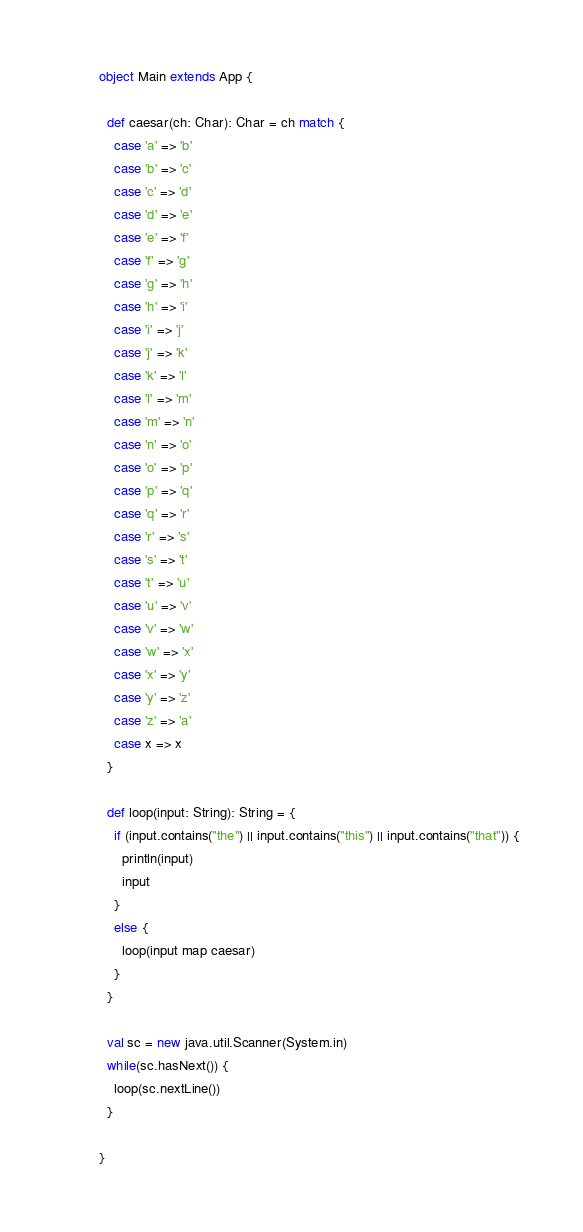<code> <loc_0><loc_0><loc_500><loc_500><_Scala_>object Main extends App {

  def caesar(ch: Char): Char = ch match {
    case 'a' => 'b'
    case 'b' => 'c'
    case 'c' => 'd'
    case 'd' => 'e'
    case 'e' => 'f'
    case 'f' => 'g'
    case 'g' => 'h'
    case 'h' => 'i'
    case 'i' => 'j'
    case 'j' => 'k'
    case 'k' => 'l'
    case 'l' => 'm'
    case 'm' => 'n'
    case 'n' => 'o'
    case 'o' => 'p'
    case 'p' => 'q'
    case 'q' => 'r'
    case 'r' => 's'
    case 's' => 't'
    case 't' => 'u'
    case 'u' => 'v'
    case 'v' => 'w'
    case 'w' => 'x'
    case 'x' => 'y'
    case 'y' => 'z'
    case 'z' => 'a'
    case x => x
  }

  def loop(input: String): String = {
    if (input.contains("the") || input.contains("this") || input.contains("that")) {
      println(input)
      input
    }
    else {
      loop(input map caesar)
    }
  }

  val sc = new java.util.Scanner(System.in)
  while(sc.hasNext()) {
    loop(sc.nextLine())
  }

}</code> 